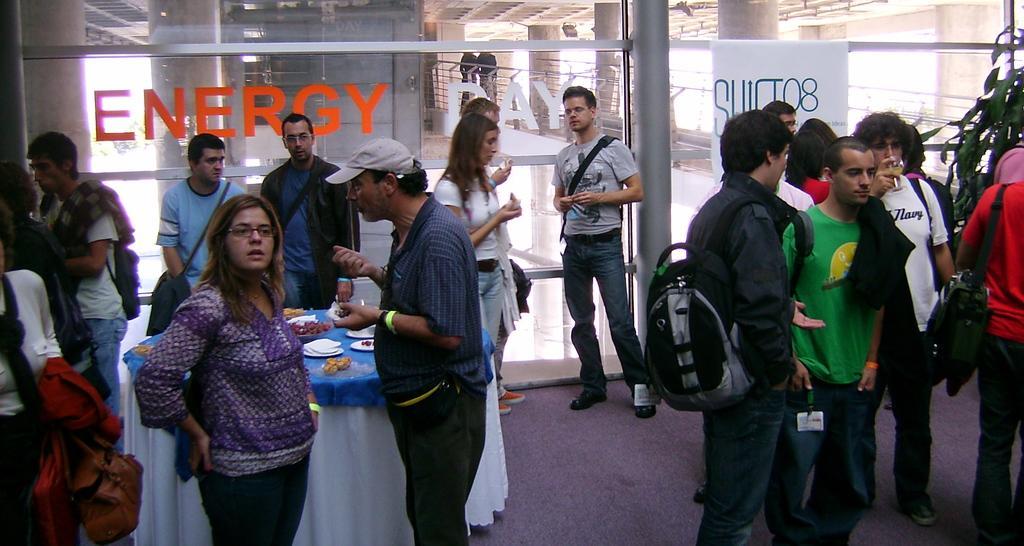Describe this image in one or two sentences. In this picture we can see a group of people and a table on the ground and the table is covered by a cloth. On the table, there are plates and some food items. Behind the people, there are glass doors. Behind the glass doors, there are pillars and railing. On the right side of the image, there is a houseplant. 